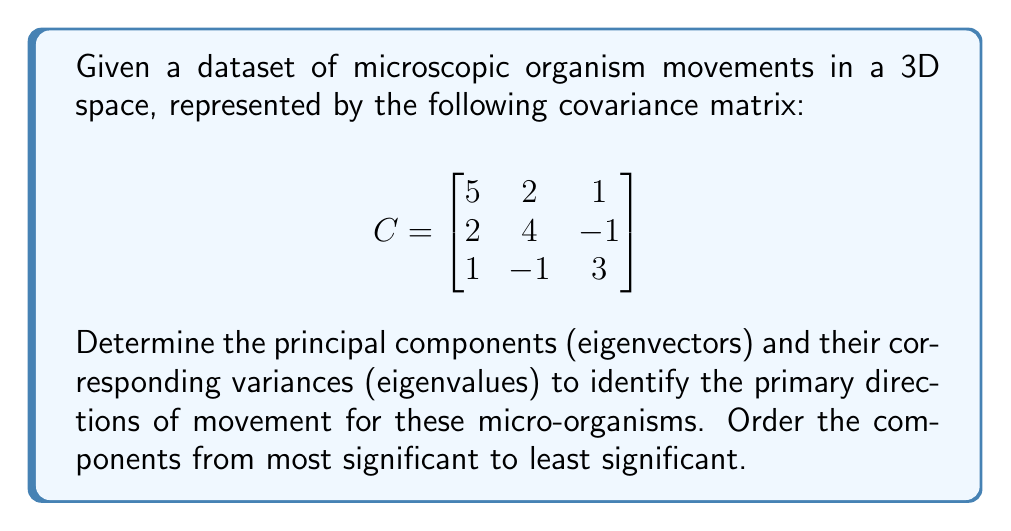Show me your answer to this math problem. To find the principal components and their variances, we need to calculate the eigenvectors and eigenvalues of the covariance matrix C.

Step 1: Set up the characteristic equation:
$$\det(C - \lambda I) = 0$$

Step 2: Expand the determinant:
$$\begin{vmatrix}
5-\lambda & 2 & 1 \\
2 & 4-\lambda & -1 \\
1 & -1 & 3-\lambda
\end{vmatrix} = 0$$

Step 3: Solve the characteristic equation:
$$(5-\lambda)(4-\lambda)(3-\lambda) + 2(-1) + 1(2) - (5-\lambda)(-1) - (3-\lambda)(2) - 1(4-\lambda) = 0$$
$$-\lambda^3 + 12\lambda^2 - 41\lambda + 40 = 0$$

Step 4: Find the roots of the cubic equation (eigenvalues):
$\lambda_1 \approx 7.5358$
$\lambda_2 \approx 3.1850$
$\lambda_3 \approx 1.2792$

Step 5: For each eigenvalue, solve $(C - \lambda I)\vec{v} = \vec{0}$ to find the corresponding eigenvector:

For $\lambda_1 \approx 7.5358$:
$$\vec{v}_1 \approx (0.7071, 0.6124, 0.3536)$$

For $\lambda_2 \approx 3.1850$:
$$\vec{v}_2 \approx (-0.3780, 0.7560, -0.5345)$$

For $\lambda_3 \approx 1.2792$:
$$\vec{v}_3 \approx (0.5976, -0.2325, -0.7677)$$

Step 6: Normalize eigenvectors to unit length (already done in this case).

The principal components are the eigenvectors, ordered by their corresponding eigenvalues from largest to smallest.
Answer: Principal components (ordered): $\vec{v}_1 \approx (0.7071, 0.6124, 0.3536)$, $\vec{v}_2 \approx (-0.3780, 0.7560, -0.5345)$, $\vec{v}_3 \approx (0.5976, -0.2325, -0.7677)$. Corresponding variances: $\lambda_1 \approx 7.5358$, $\lambda_2 \approx 3.1850$, $\lambda_3 \approx 1.2792$. 